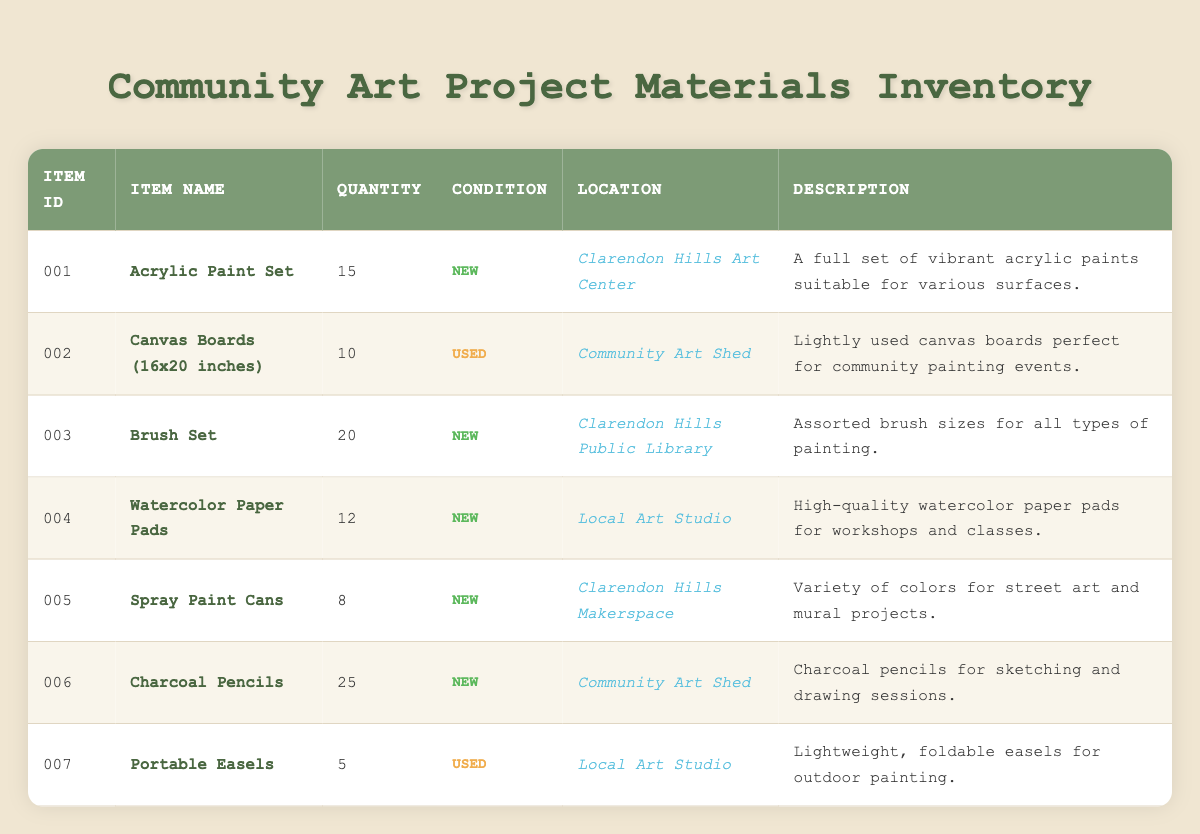What is the quantity of the Acrylic Paint Set? The Acrylic Paint Set has an item ID of 001, and the quantity column indicates that there are 15 units available.
Answer: 15 Where are the Brush Sets located? The Brush Set has an item ID of 003, and the location column specifies it can be found at the Clarendon Hills Public Library.
Answer: Clarendon Hills Public Library Is there any used item in the inventory? To determine this, we need to look at the condition column. The Canvas Boards and Portable Easels are listed as "Used," indicating that there are used items available.
Answer: Yes What is the total number of new supplies listed in the inventory? We examine the condition column for items marked as "New." The items are Acrylic Paint Set (15), Brush Set (20), Watercolor Paper Pads (12), Spray Paint Cans (8), and Charcoal Pencils (25). Summing these gives 15 + 20 + 12 + 8 + 25 = 80 units.
Answer: 80 How many more Charcoal Pencils are there than Spray Paint Cans? We find that there are 25 Charcoal Pencils and 8 Spray Paint Cans. The difference can be calculated by subtracting the quantity of Spray Paint Cans from that of Charcoal Pencils: 25 - 8 = 17.
Answer: 17 Which location has the highest quantity of items available? We will check each location’s total availability: Clarendon Hills Art Center (15), Community Art Shed (35 total: 10 + 25), Clarendon Hills Public Library (20), Local Art Studio (17 total: 12 + 5), and Clarendon Hills Makerspace (8). The Community Art Shed has 35, which is the highest.
Answer: Community Art Shed Are there any items with a quantity of less than 10? Review the quantity column for each item: Acrylic Paint Set (15), Canvas Boards (10), Brush Set (20), Watercolor Paper Pads (12), Spray Paint Cans (8), Charcoal Pencils (25), and Portable Easels (5). Spray Paint Cans and Portable Easels are below 10, confirming the presence of such items.
Answer: Yes What is the average quantity of items in the inventory? To find the average, we first sum the quantities: 15 + 10 + 20 + 12 + 8 + 25 + 5 = 105. There are 7 items, so to find the average, we divide the total by the number of items: 105 / 7 = 15.
Answer: 15 How many items are available for street art and mural projects? The item that specifically mentions suitability for street art is the Spray Paint Cans. It has a quantity of 8, which indicates these supplies are specifically for street art projects.
Answer: 8 